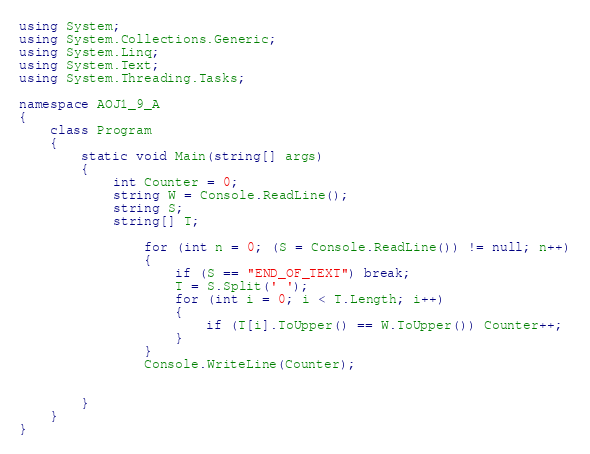<code> <loc_0><loc_0><loc_500><loc_500><_C#_>using System;
using System.Collections.Generic;
using System.Linq;
using System.Text;
using System.Threading.Tasks;

namespace AOJ1_9_A
{
    class Program
    {
        static void Main(string[] args)
        {
            int Counter = 0;
            string W = Console.ReadLine();
            string S;
            string[] T;

                for (int n = 0; (S = Console.ReadLine()) != null; n++)
                {
                    if (S == "END_OF_TEXT") break;
                    T = S.Split(' ');
                    for (int i = 0; i < T.Length; i++)
                    {
                        if (T[i].ToUpper() == W.ToUpper()) Counter++;
                    }
                }
                Console.WriteLine(Counter);

           
        }
    }
}


</code> 